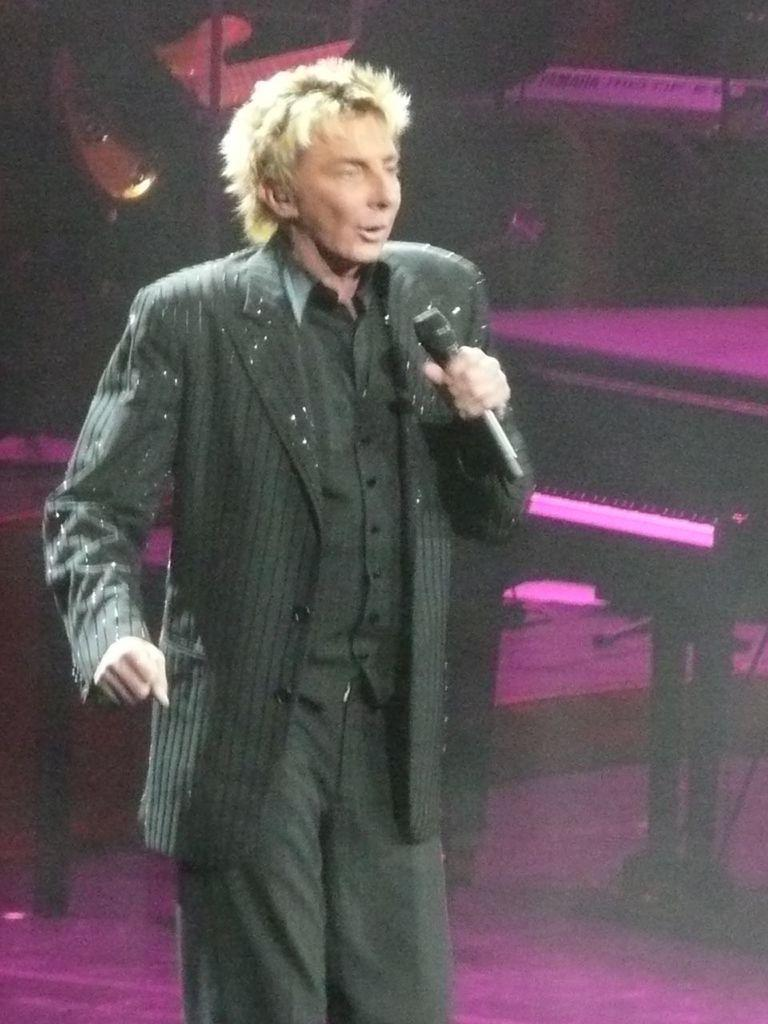What is the person in the image doing? The person is standing in the image and holding a microphone. What is the person wearing? The person is wearing a black dress. What can be seen in the background of the image? There are musical instruments in the background of the image. How many pizzas are being delivered in the image? There are no pizzas or delivery mentioned in the image; it features a person holding a microphone and wearing a black dress, with musical instruments in the background. 